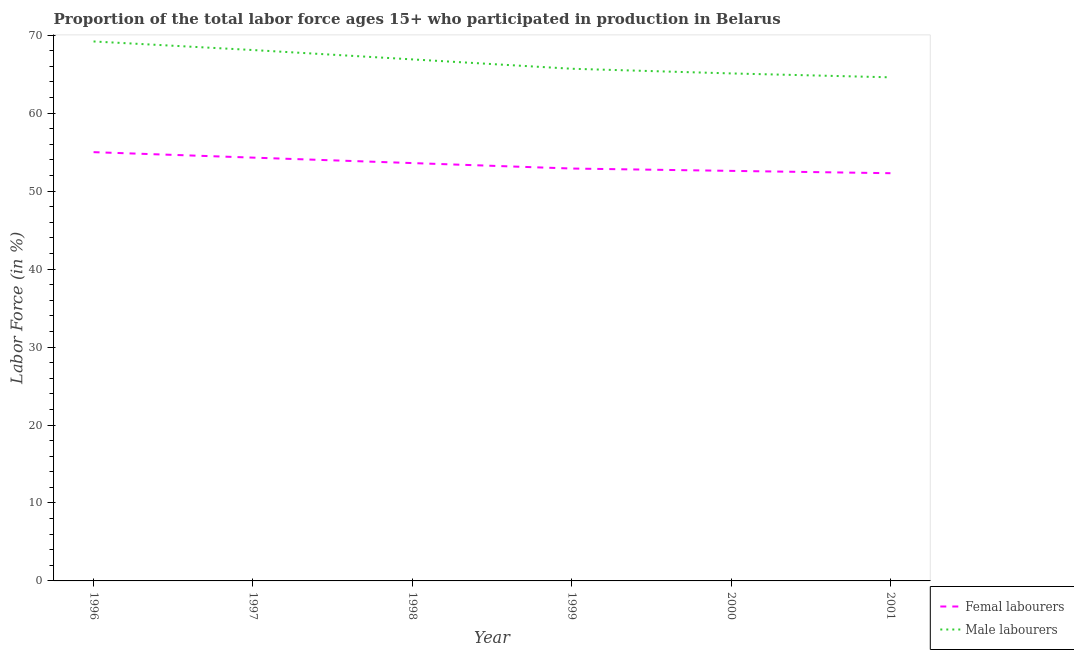Does the line corresponding to percentage of female labor force intersect with the line corresponding to percentage of male labour force?
Offer a very short reply. No. Is the number of lines equal to the number of legend labels?
Keep it short and to the point. Yes. What is the percentage of female labor force in 1998?
Provide a short and direct response. 53.6. Across all years, what is the maximum percentage of female labor force?
Provide a short and direct response. 55. Across all years, what is the minimum percentage of male labour force?
Offer a very short reply. 64.6. What is the total percentage of female labor force in the graph?
Provide a succinct answer. 320.7. What is the difference between the percentage of female labor force in 1997 and that in 1999?
Offer a very short reply. 1.4. What is the difference between the percentage of male labour force in 2000 and the percentage of female labor force in 1998?
Offer a very short reply. 11.5. What is the average percentage of male labour force per year?
Offer a very short reply. 66.6. In the year 2000, what is the difference between the percentage of male labour force and percentage of female labor force?
Your answer should be compact. 12.5. In how many years, is the percentage of male labour force greater than 42 %?
Provide a succinct answer. 6. What is the ratio of the percentage of male labour force in 1999 to that in 2001?
Offer a very short reply. 1.02. Is the difference between the percentage of female labor force in 1996 and 2001 greater than the difference between the percentage of male labour force in 1996 and 2001?
Your response must be concise. No. What is the difference between the highest and the second highest percentage of female labor force?
Keep it short and to the point. 0.7. What is the difference between the highest and the lowest percentage of female labor force?
Offer a very short reply. 2.7. In how many years, is the percentage of male labour force greater than the average percentage of male labour force taken over all years?
Your answer should be very brief. 3. Does the percentage of male labour force monotonically increase over the years?
Keep it short and to the point. No. How many lines are there?
Your answer should be compact. 2. How many years are there in the graph?
Give a very brief answer. 6. What is the difference between two consecutive major ticks on the Y-axis?
Ensure brevity in your answer.  10. Does the graph contain any zero values?
Provide a succinct answer. No. Where does the legend appear in the graph?
Make the answer very short. Bottom right. How are the legend labels stacked?
Ensure brevity in your answer.  Vertical. What is the title of the graph?
Keep it short and to the point. Proportion of the total labor force ages 15+ who participated in production in Belarus. Does "Male labourers" appear as one of the legend labels in the graph?
Your response must be concise. Yes. What is the label or title of the Y-axis?
Provide a short and direct response. Labor Force (in %). What is the Labor Force (in %) of Male labourers in 1996?
Give a very brief answer. 69.2. What is the Labor Force (in %) of Femal labourers in 1997?
Ensure brevity in your answer.  54.3. What is the Labor Force (in %) of Male labourers in 1997?
Offer a very short reply. 68.1. What is the Labor Force (in %) of Femal labourers in 1998?
Keep it short and to the point. 53.6. What is the Labor Force (in %) of Male labourers in 1998?
Your response must be concise. 66.9. What is the Labor Force (in %) in Femal labourers in 1999?
Your answer should be compact. 52.9. What is the Labor Force (in %) of Male labourers in 1999?
Offer a terse response. 65.7. What is the Labor Force (in %) of Femal labourers in 2000?
Make the answer very short. 52.6. What is the Labor Force (in %) of Male labourers in 2000?
Provide a succinct answer. 65.1. What is the Labor Force (in %) in Femal labourers in 2001?
Offer a terse response. 52.3. What is the Labor Force (in %) of Male labourers in 2001?
Give a very brief answer. 64.6. Across all years, what is the maximum Labor Force (in %) of Femal labourers?
Offer a very short reply. 55. Across all years, what is the maximum Labor Force (in %) of Male labourers?
Your response must be concise. 69.2. Across all years, what is the minimum Labor Force (in %) of Femal labourers?
Ensure brevity in your answer.  52.3. Across all years, what is the minimum Labor Force (in %) in Male labourers?
Make the answer very short. 64.6. What is the total Labor Force (in %) in Femal labourers in the graph?
Ensure brevity in your answer.  320.7. What is the total Labor Force (in %) in Male labourers in the graph?
Offer a very short reply. 399.6. What is the difference between the Labor Force (in %) of Male labourers in 1996 and that in 1997?
Make the answer very short. 1.1. What is the difference between the Labor Force (in %) of Femal labourers in 1996 and that in 2001?
Offer a very short reply. 2.7. What is the difference between the Labor Force (in %) of Femal labourers in 1997 and that in 1998?
Make the answer very short. 0.7. What is the difference between the Labor Force (in %) of Male labourers in 1997 and that in 1998?
Offer a terse response. 1.2. What is the difference between the Labor Force (in %) in Femal labourers in 1997 and that in 1999?
Offer a very short reply. 1.4. What is the difference between the Labor Force (in %) of Femal labourers in 1997 and that in 2000?
Ensure brevity in your answer.  1.7. What is the difference between the Labor Force (in %) of Male labourers in 1997 and that in 2000?
Offer a terse response. 3. What is the difference between the Labor Force (in %) of Male labourers in 1997 and that in 2001?
Your response must be concise. 3.5. What is the difference between the Labor Force (in %) of Femal labourers in 1998 and that in 1999?
Ensure brevity in your answer.  0.7. What is the difference between the Labor Force (in %) in Male labourers in 1998 and that in 1999?
Your answer should be compact. 1.2. What is the difference between the Labor Force (in %) of Male labourers in 1998 and that in 2000?
Give a very brief answer. 1.8. What is the difference between the Labor Force (in %) in Femal labourers in 1999 and that in 2000?
Keep it short and to the point. 0.3. What is the difference between the Labor Force (in %) in Femal labourers in 1999 and that in 2001?
Your answer should be very brief. 0.6. What is the difference between the Labor Force (in %) in Male labourers in 1999 and that in 2001?
Make the answer very short. 1.1. What is the difference between the Labor Force (in %) of Femal labourers in 2000 and that in 2001?
Your response must be concise. 0.3. What is the difference between the Labor Force (in %) in Femal labourers in 1996 and the Labor Force (in %) in Male labourers in 2000?
Give a very brief answer. -10.1. What is the difference between the Labor Force (in %) of Femal labourers in 1996 and the Labor Force (in %) of Male labourers in 2001?
Keep it short and to the point. -9.6. What is the difference between the Labor Force (in %) of Femal labourers in 1997 and the Labor Force (in %) of Male labourers in 1998?
Keep it short and to the point. -12.6. What is the difference between the Labor Force (in %) of Femal labourers in 1997 and the Labor Force (in %) of Male labourers in 2001?
Provide a succinct answer. -10.3. What is the difference between the Labor Force (in %) in Femal labourers in 1998 and the Labor Force (in %) in Male labourers in 1999?
Offer a terse response. -12.1. What is the difference between the Labor Force (in %) in Femal labourers in 1998 and the Labor Force (in %) in Male labourers in 2001?
Give a very brief answer. -11. What is the difference between the Labor Force (in %) in Femal labourers in 1999 and the Labor Force (in %) in Male labourers in 2000?
Offer a terse response. -12.2. What is the difference between the Labor Force (in %) of Femal labourers in 1999 and the Labor Force (in %) of Male labourers in 2001?
Your answer should be compact. -11.7. What is the difference between the Labor Force (in %) of Femal labourers in 2000 and the Labor Force (in %) of Male labourers in 2001?
Give a very brief answer. -12. What is the average Labor Force (in %) of Femal labourers per year?
Give a very brief answer. 53.45. What is the average Labor Force (in %) of Male labourers per year?
Make the answer very short. 66.6. In the year 1996, what is the difference between the Labor Force (in %) in Femal labourers and Labor Force (in %) in Male labourers?
Keep it short and to the point. -14.2. In the year 1997, what is the difference between the Labor Force (in %) of Femal labourers and Labor Force (in %) of Male labourers?
Ensure brevity in your answer.  -13.8. In the year 1998, what is the difference between the Labor Force (in %) in Femal labourers and Labor Force (in %) in Male labourers?
Your response must be concise. -13.3. In the year 2000, what is the difference between the Labor Force (in %) of Femal labourers and Labor Force (in %) of Male labourers?
Provide a short and direct response. -12.5. What is the ratio of the Labor Force (in %) of Femal labourers in 1996 to that in 1997?
Make the answer very short. 1.01. What is the ratio of the Labor Force (in %) in Male labourers in 1996 to that in 1997?
Your answer should be compact. 1.02. What is the ratio of the Labor Force (in %) in Femal labourers in 1996 to that in 1998?
Keep it short and to the point. 1.03. What is the ratio of the Labor Force (in %) of Male labourers in 1996 to that in 1998?
Give a very brief answer. 1.03. What is the ratio of the Labor Force (in %) of Femal labourers in 1996 to that in 1999?
Make the answer very short. 1.04. What is the ratio of the Labor Force (in %) in Male labourers in 1996 to that in 1999?
Offer a very short reply. 1.05. What is the ratio of the Labor Force (in %) in Femal labourers in 1996 to that in 2000?
Provide a short and direct response. 1.05. What is the ratio of the Labor Force (in %) of Male labourers in 1996 to that in 2000?
Your answer should be compact. 1.06. What is the ratio of the Labor Force (in %) in Femal labourers in 1996 to that in 2001?
Ensure brevity in your answer.  1.05. What is the ratio of the Labor Force (in %) of Male labourers in 1996 to that in 2001?
Your response must be concise. 1.07. What is the ratio of the Labor Force (in %) of Femal labourers in 1997 to that in 1998?
Offer a very short reply. 1.01. What is the ratio of the Labor Force (in %) of Male labourers in 1997 to that in 1998?
Offer a terse response. 1.02. What is the ratio of the Labor Force (in %) in Femal labourers in 1997 to that in 1999?
Make the answer very short. 1.03. What is the ratio of the Labor Force (in %) in Male labourers in 1997 to that in 1999?
Provide a succinct answer. 1.04. What is the ratio of the Labor Force (in %) of Femal labourers in 1997 to that in 2000?
Your response must be concise. 1.03. What is the ratio of the Labor Force (in %) in Male labourers in 1997 to that in 2000?
Provide a succinct answer. 1.05. What is the ratio of the Labor Force (in %) in Femal labourers in 1997 to that in 2001?
Provide a short and direct response. 1.04. What is the ratio of the Labor Force (in %) in Male labourers in 1997 to that in 2001?
Provide a short and direct response. 1.05. What is the ratio of the Labor Force (in %) of Femal labourers in 1998 to that in 1999?
Offer a terse response. 1.01. What is the ratio of the Labor Force (in %) of Male labourers in 1998 to that in 1999?
Offer a terse response. 1.02. What is the ratio of the Labor Force (in %) in Femal labourers in 1998 to that in 2000?
Give a very brief answer. 1.02. What is the ratio of the Labor Force (in %) in Male labourers in 1998 to that in 2000?
Provide a succinct answer. 1.03. What is the ratio of the Labor Force (in %) of Femal labourers in 1998 to that in 2001?
Your response must be concise. 1.02. What is the ratio of the Labor Force (in %) in Male labourers in 1998 to that in 2001?
Your response must be concise. 1.04. What is the ratio of the Labor Force (in %) in Femal labourers in 1999 to that in 2000?
Offer a terse response. 1.01. What is the ratio of the Labor Force (in %) in Male labourers in 1999 to that in 2000?
Ensure brevity in your answer.  1.01. What is the ratio of the Labor Force (in %) in Femal labourers in 1999 to that in 2001?
Provide a short and direct response. 1.01. What is the ratio of the Labor Force (in %) in Male labourers in 1999 to that in 2001?
Make the answer very short. 1.02. What is the ratio of the Labor Force (in %) of Femal labourers in 2000 to that in 2001?
Give a very brief answer. 1.01. What is the ratio of the Labor Force (in %) in Male labourers in 2000 to that in 2001?
Your response must be concise. 1.01. What is the difference between the highest and the second highest Labor Force (in %) in Femal labourers?
Ensure brevity in your answer.  0.7. What is the difference between the highest and the second highest Labor Force (in %) in Male labourers?
Make the answer very short. 1.1. 